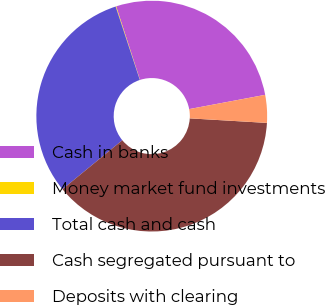Convert chart to OTSL. <chart><loc_0><loc_0><loc_500><loc_500><pie_chart><fcel>Cash in banks<fcel>Money market fund investments<fcel>Total cash and cash<fcel>Cash segregated pursuant to<fcel>Deposits with clearing<nl><fcel>27.04%<fcel>0.08%<fcel>30.85%<fcel>38.14%<fcel>3.89%<nl></chart> 